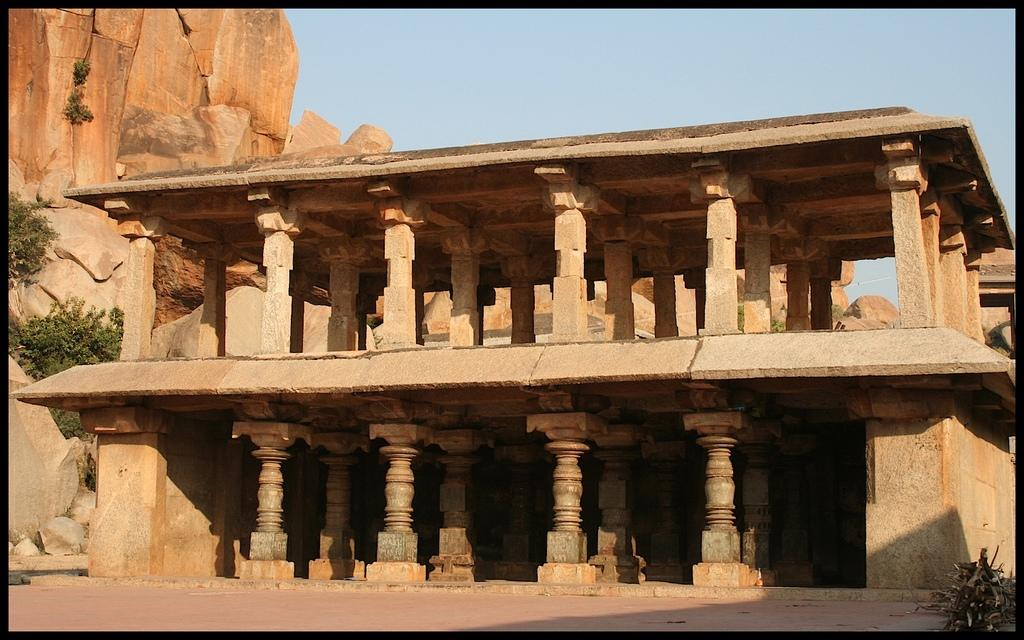What is the main structure in the image? There is a monument in the image. What can be seen on the left side of the image? There are plants and rocks on the left side of the image. Is there any vegetation in the bottom right corner of the image? Yes, there is a plant in the bottom right corner of the image. What is visible at the top of the image? The sky is visible at the top of the image. What type of wood is used to construct the monument in the image? There is no mention of wood being used in the construction of the monument in the image. 